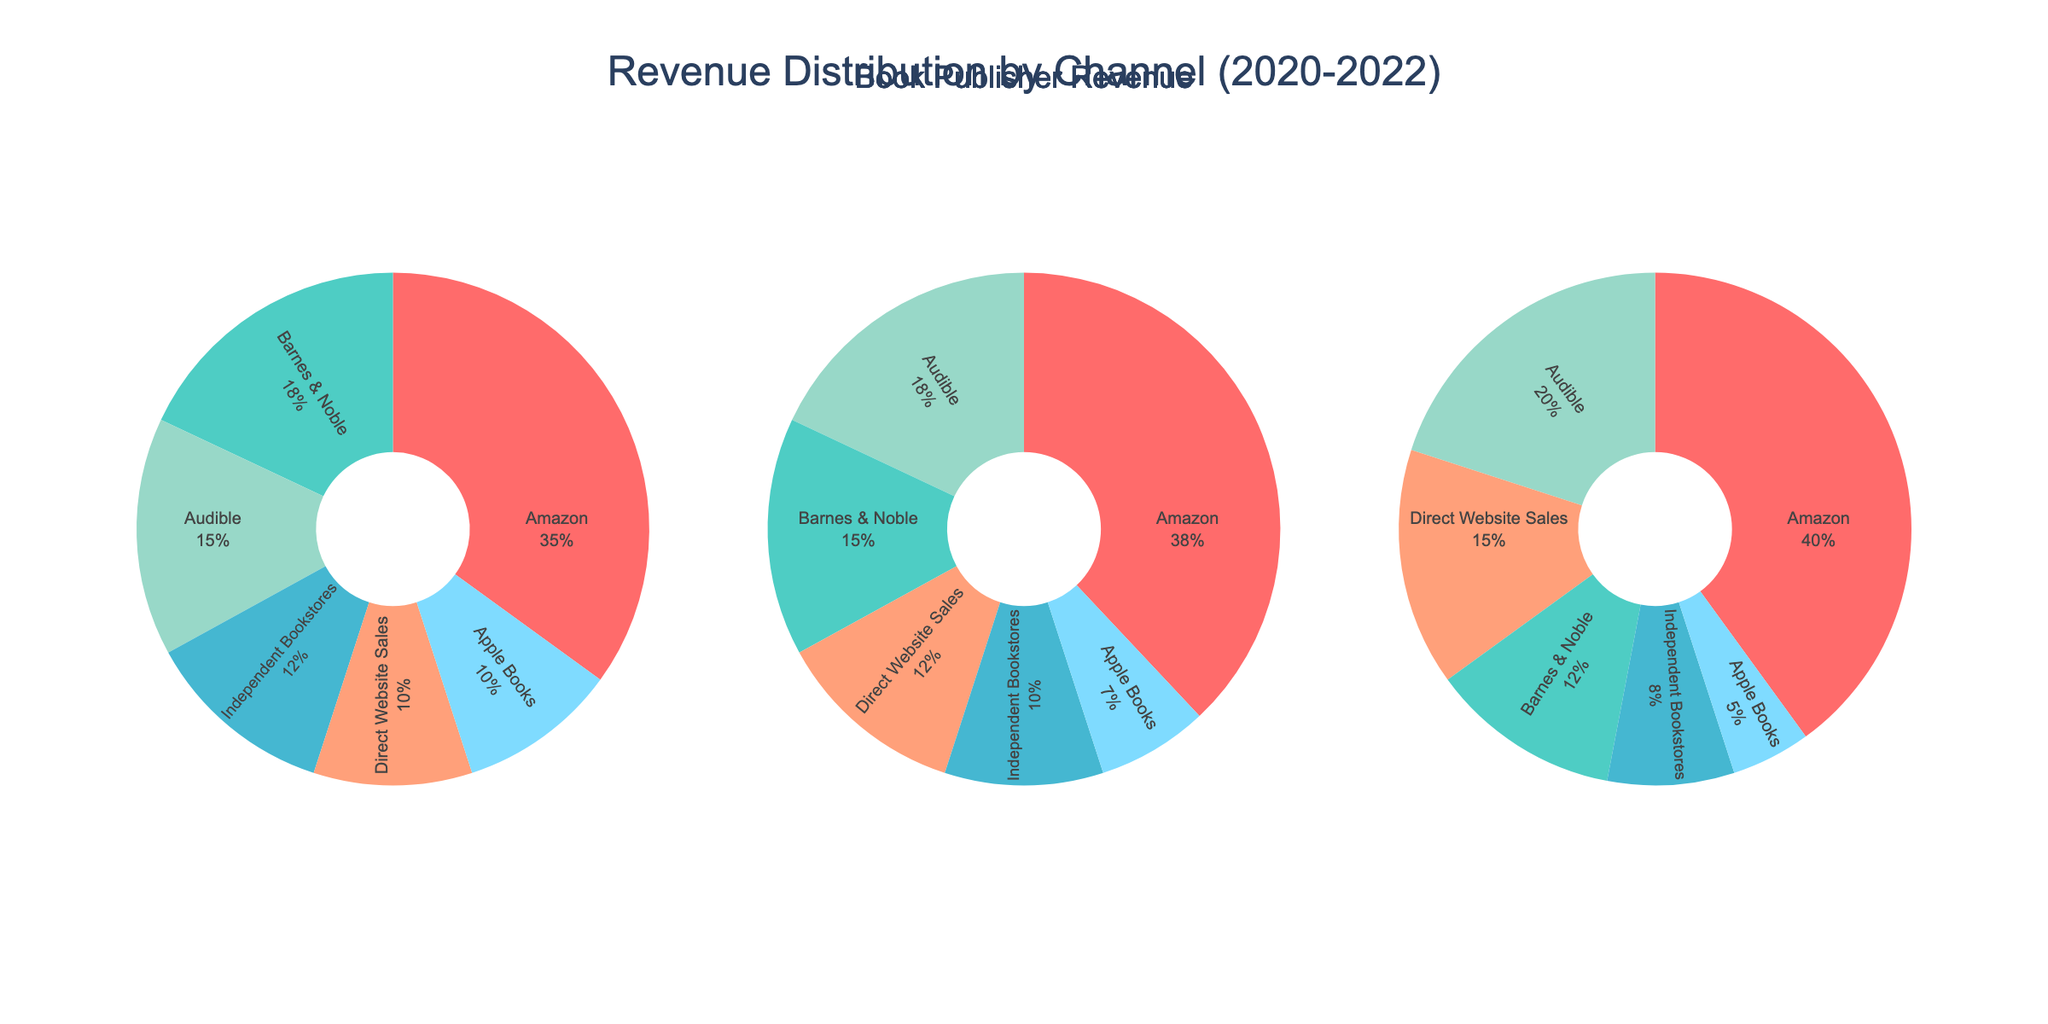What is the title of the figure? The title is located at the top of the figure and it is centered.
Answer: Revenue Distribution by Channel (2020-2022) Which year had the highest revenue for Amazon? By examining the pie charts for each year, we can see the percentages for Amazon are highest in 2022.
Answer: 2022 What was the revenue percentage for Audible in 2021? Audible's share can be seen on the 2021 pie chart labeled in the middle; it shows 18%.
Answer: 18% What is the total combined revenue for physical bookstores in 2022? The combined total for Barnes & Noble and Independent Bookstores in 2022 can be calculated: 12 + 8 = 20.
Answer: 20 Which channel showed consistent revenue growth over the 3 years? By comparing the segment sizes for each channel over each year, we can observe that Direct Website Sales have increased yearly from 10 in 2020, to 12 in 2021, and then to 15 in 2022.
Answer: Direct Website Sales What was the difference in revenue between Barnes & Noble and Amazon in 2020? By looking at the 2020 pie chart, Barnes & Noble had a revenue of 18, and Amazon had 35. The difference is 35 - 18 = 17.
Answer: 17 Which year had the smallest revenue share for Independent Bookstores? By comparing the pie charts across the years, 2022 shows the smallest segment for Independent Bookstores with 8.
Answer: 2022 In 2020, which channel had the second highest revenue? The pie chart for 2020 shows that Audible has the second largest segment after Amazon.
Answer: Audible How does the revenue from physical bookstores compare between 2020 and 2021? Summing up the revenues for Barnes & Noble and Independent Bookstores for both years: 2020 total = 18 + 12 = 30, 2021 total = 15 + 10 = 25.
Answer: Decreased by 5 What is the average revenue for Apple Books over the three years? Apple Books had revenues of 10, 7, and 5 over the three years. The average is calculated as (10 + 7 + 5) / 3 = 7.33.
Answer: 7.33 